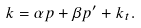Convert formula to latex. <formula><loc_0><loc_0><loc_500><loc_500>k = \alpha p + \beta p ^ { \prime } + k _ { t } .</formula> 